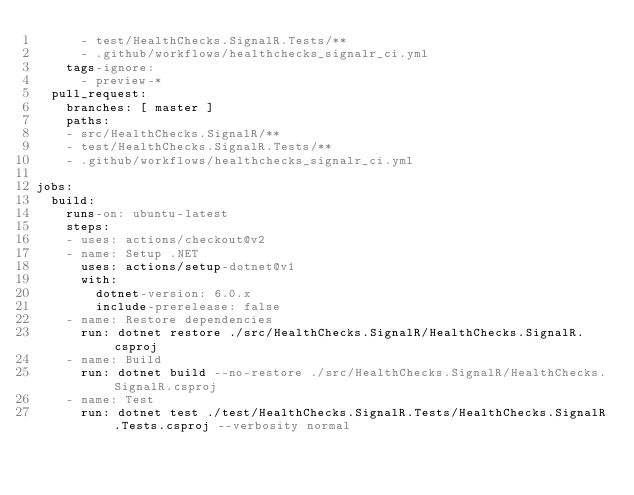<code> <loc_0><loc_0><loc_500><loc_500><_YAML_>      - test/HealthChecks.SignalR.Tests/**
      - .github/workflows/healthchecks_signalr_ci.yml
    tags-ignore:
      - preview-*
  pull_request:
    branches: [ master ]
    paths:
    - src/HealthChecks.SignalR/**
    - test/HealthChecks.SignalR.Tests/**
    - .github/workflows/healthchecks_signalr_ci.yml

jobs:
  build:
    runs-on: ubuntu-latest
    steps:
    - uses: actions/checkout@v2
    - name: Setup .NET
      uses: actions/setup-dotnet@v1
      with:
        dotnet-version: 6.0.x
        include-prerelease: false
    - name: Restore dependencies
      run: dotnet restore ./src/HealthChecks.SignalR/HealthChecks.SignalR.csproj
    - name: Build
      run: dotnet build --no-restore ./src/HealthChecks.SignalR/HealthChecks.SignalR.csproj
    - name: Test
      run: dotnet test ./test/HealthChecks.SignalR.Tests/HealthChecks.SignalR.Tests.csproj --verbosity normal
</code> 